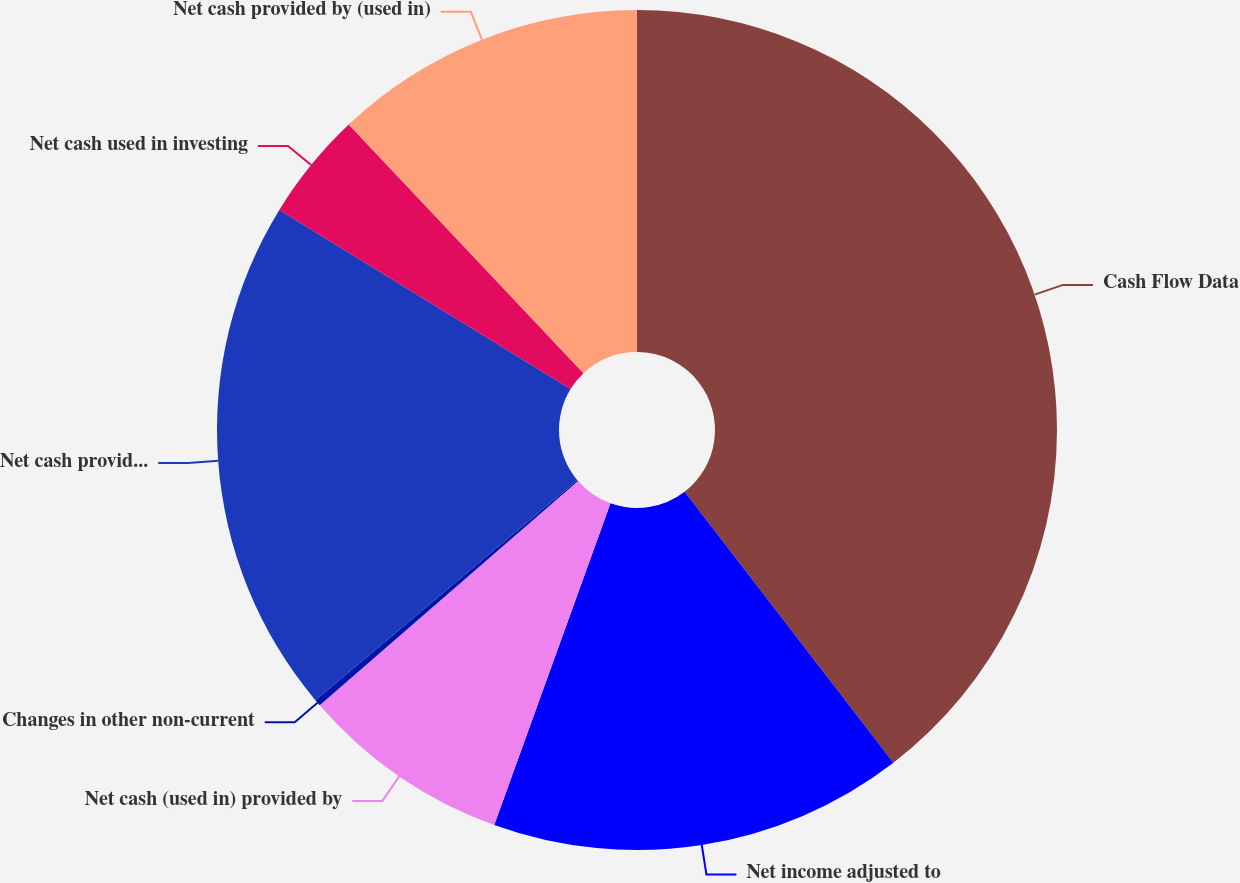Convert chart to OTSL. <chart><loc_0><loc_0><loc_500><loc_500><pie_chart><fcel>Cash Flow Data<fcel>Net income adjusted to<fcel>Net cash (used in) provided by<fcel>Changes in other non-current<fcel>Net cash provided by operating<fcel>Net cash used in investing<fcel>Net cash provided by (used in)<nl><fcel>39.55%<fcel>15.97%<fcel>8.11%<fcel>0.25%<fcel>19.9%<fcel>4.18%<fcel>12.04%<nl></chart> 